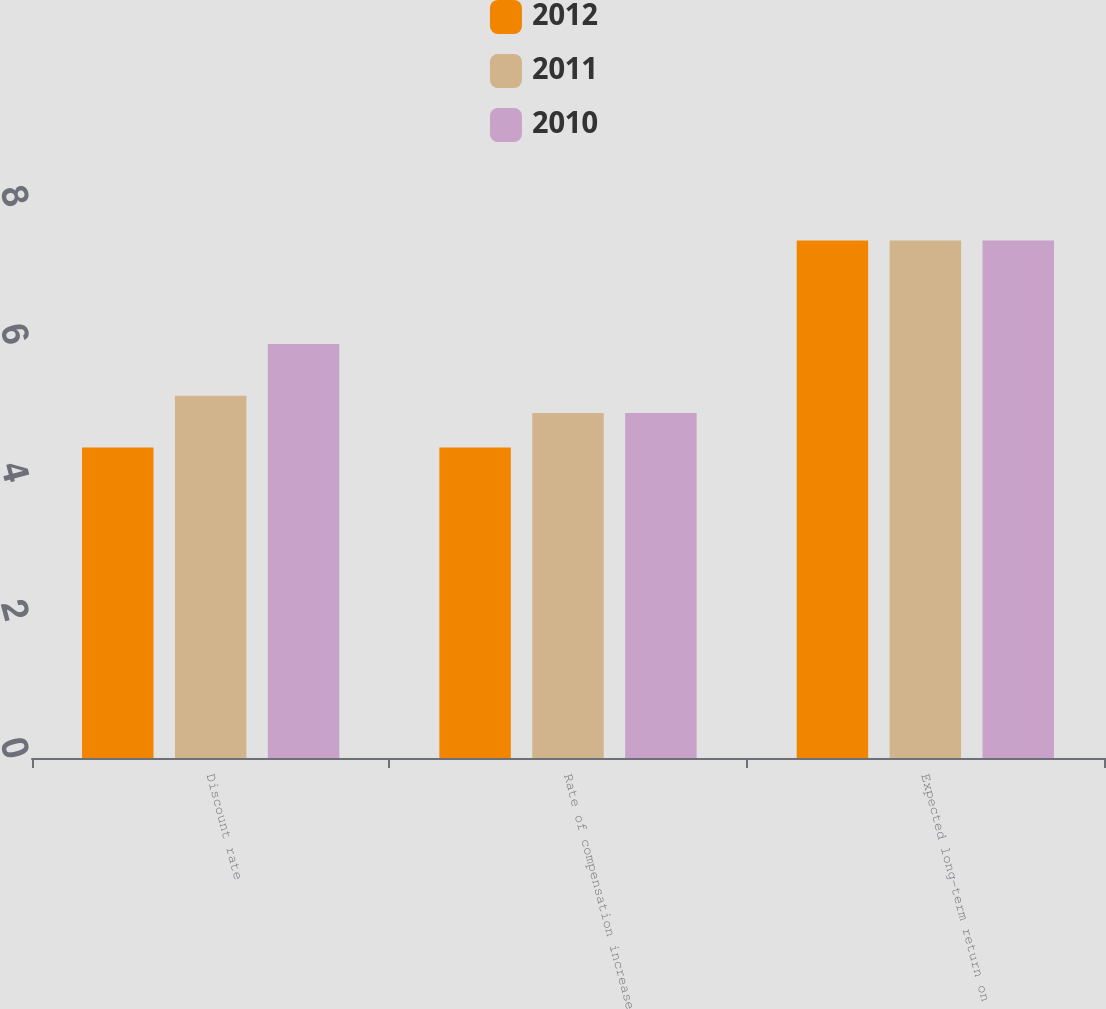Convert chart to OTSL. <chart><loc_0><loc_0><loc_500><loc_500><stacked_bar_chart><ecel><fcel>Discount rate<fcel>Rate of compensation increase<fcel>Expected long-term return on<nl><fcel>2012<fcel>4.5<fcel>4.5<fcel>7.5<nl><fcel>2011<fcel>5.25<fcel>5<fcel>7.5<nl><fcel>2010<fcel>6<fcel>5<fcel>7.5<nl></chart> 